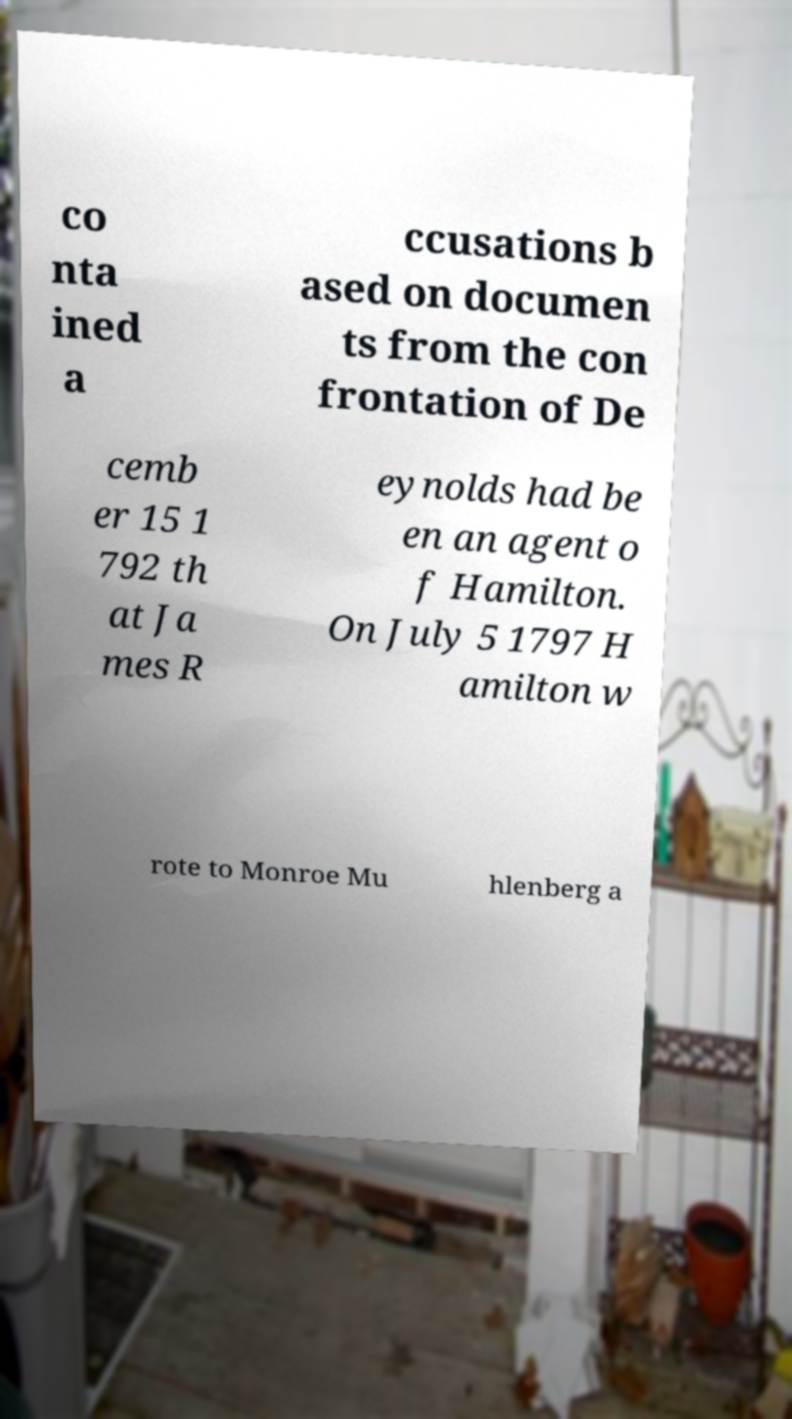Please read and relay the text visible in this image. What does it say? co nta ined a ccusations b ased on documen ts from the con frontation of De cemb er 15 1 792 th at Ja mes R eynolds had be en an agent o f Hamilton. On July 5 1797 H amilton w rote to Monroe Mu hlenberg a 